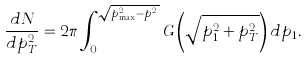Convert formula to latex. <formula><loc_0><loc_0><loc_500><loc_500>\frac { d N } { d p _ { T } ^ { 2 } } = 2 \pi \int _ { 0 } ^ { \sqrt { p _ { \max } ^ { 2 } - p _ { T } ^ { 2 } } } G \left ( \sqrt { p _ { 1 } ^ { 2 } + p _ { T } ^ { 2 } } \right ) d p _ { 1 } .</formula> 